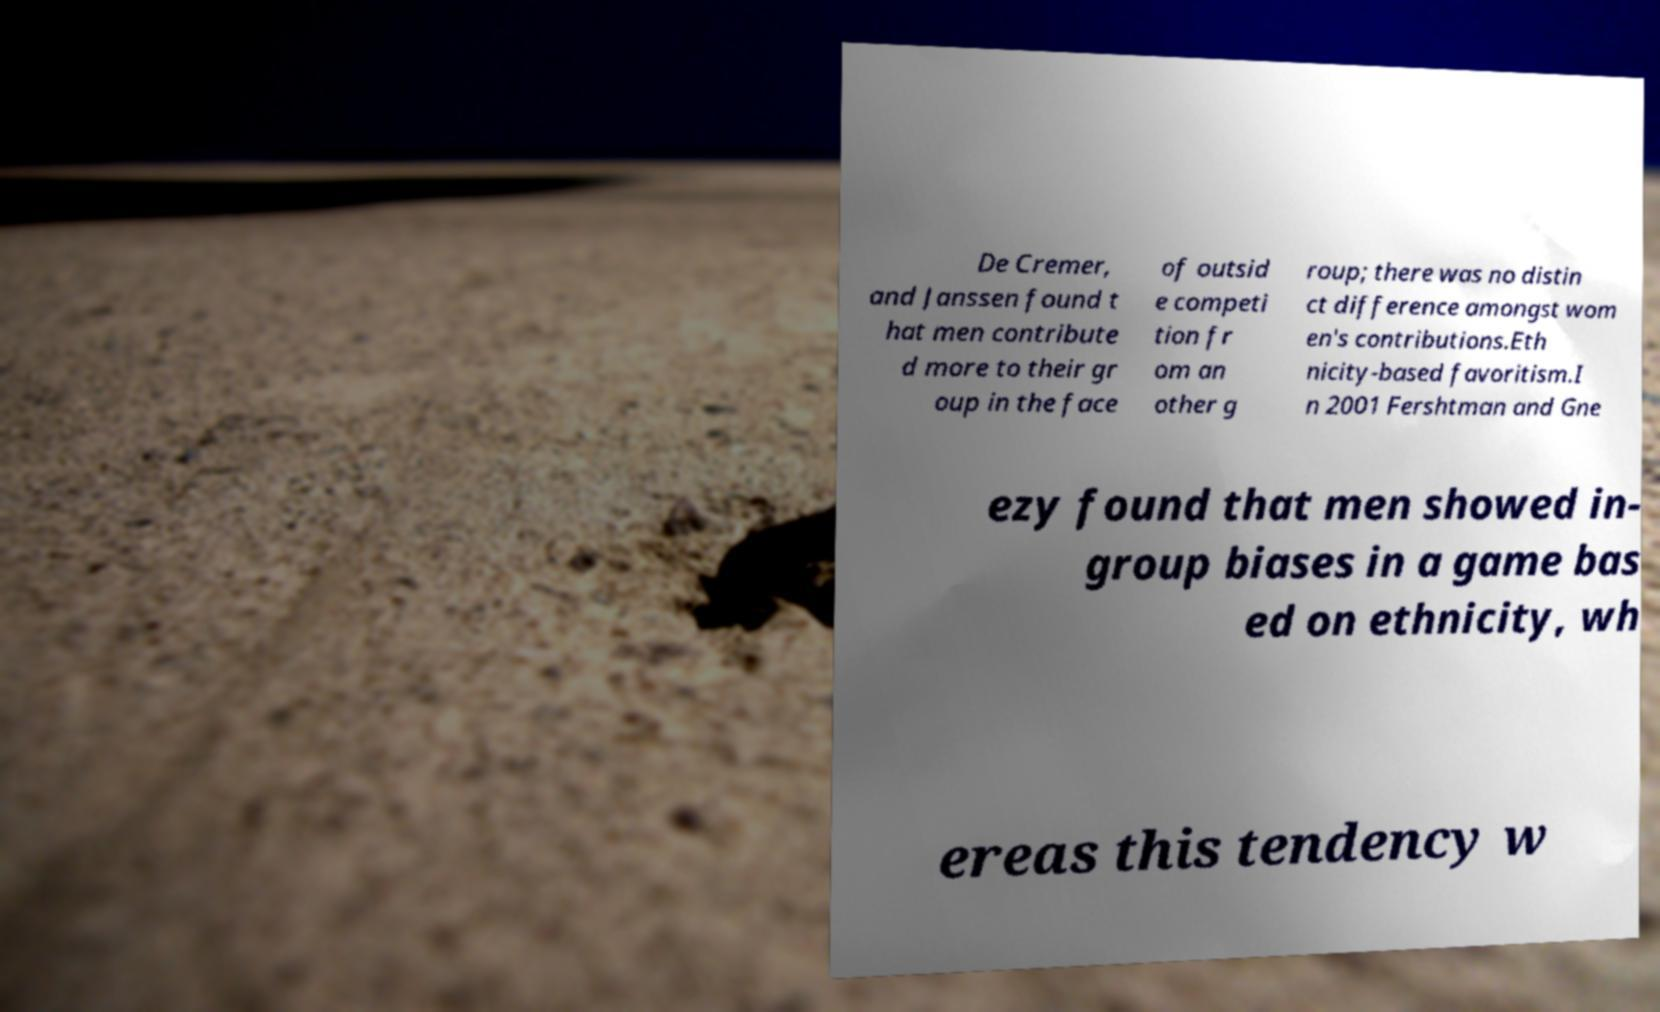I need the written content from this picture converted into text. Can you do that? De Cremer, and Janssen found t hat men contribute d more to their gr oup in the face of outsid e competi tion fr om an other g roup; there was no distin ct difference amongst wom en's contributions.Eth nicity-based favoritism.I n 2001 Fershtman and Gne ezy found that men showed in- group biases in a game bas ed on ethnicity, wh ereas this tendency w 